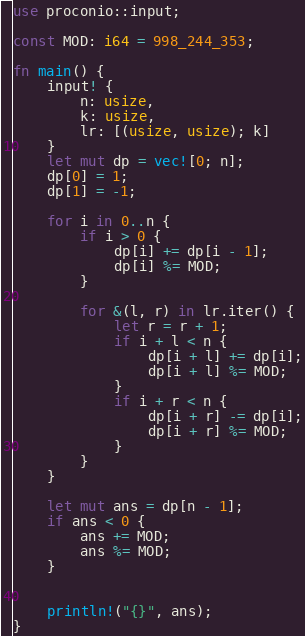Convert code to text. <code><loc_0><loc_0><loc_500><loc_500><_Rust_>use proconio::input;

const MOD: i64 = 998_244_353;

fn main() {
    input! {
        n: usize,
        k: usize,
        lr: [(usize, usize); k]
    }
    let mut dp = vec![0; n];
    dp[0] = 1;
    dp[1] = -1;

    for i in 0..n {
        if i > 0 {
            dp[i] += dp[i - 1];
            dp[i] %= MOD;
        }

        for &(l, r) in lr.iter() {
            let r = r + 1;
            if i + l < n {
                dp[i + l] += dp[i];
                dp[i + l] %= MOD;
            }
            if i + r < n {
                dp[i + r] -= dp[i];
                dp[i + r] %= MOD;
            }
        }
    }

    let mut ans = dp[n - 1];
    if ans < 0 {
        ans += MOD;
        ans %= MOD;
    }
    

    println!("{}", ans);
}
</code> 